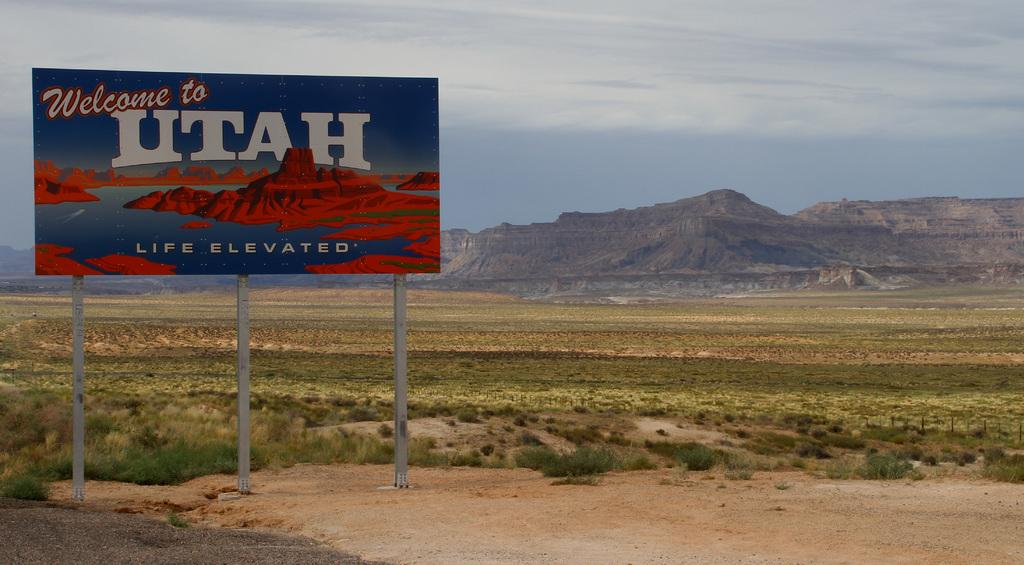<image>
Relay a brief, clear account of the picture shown. a large Welcome to Utah sign is beside the road 